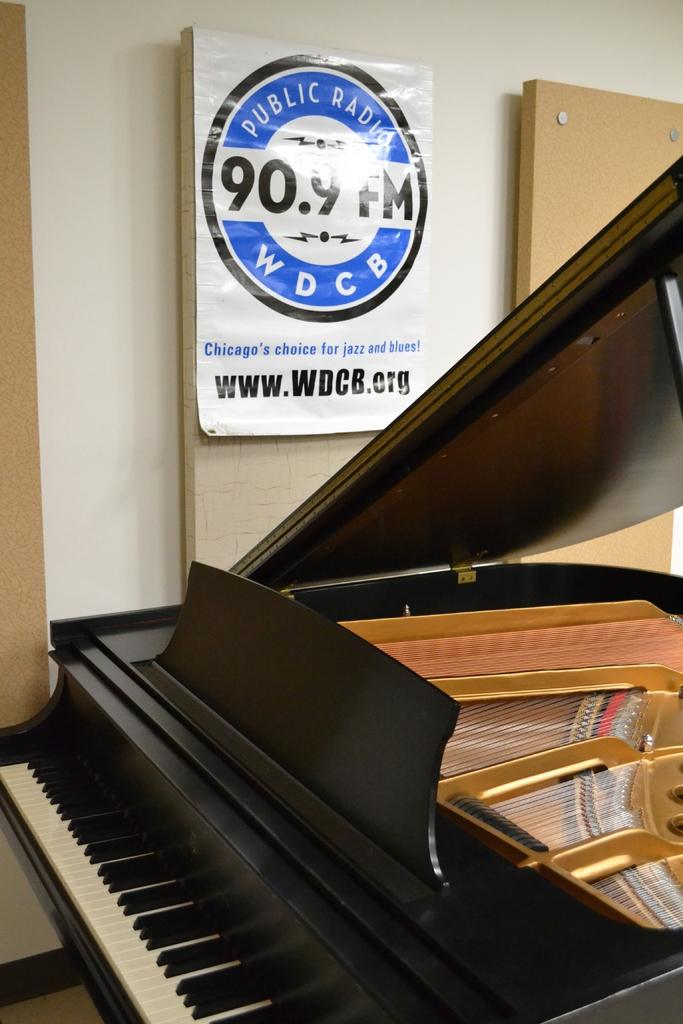What is the main object in the image? There is a piano in the image. What is the purpose of the piano? The piano is a musical instrument. What else can be seen in the image besides the piano? There is a wall in the image. Is there any decoration or additional information on the wall? Yes, there is a banner sticker on the wall. Can you tell me how many friends are sitting next to the piano in the image? There is no mention of friends or anyone sitting next to the piano in the image. 